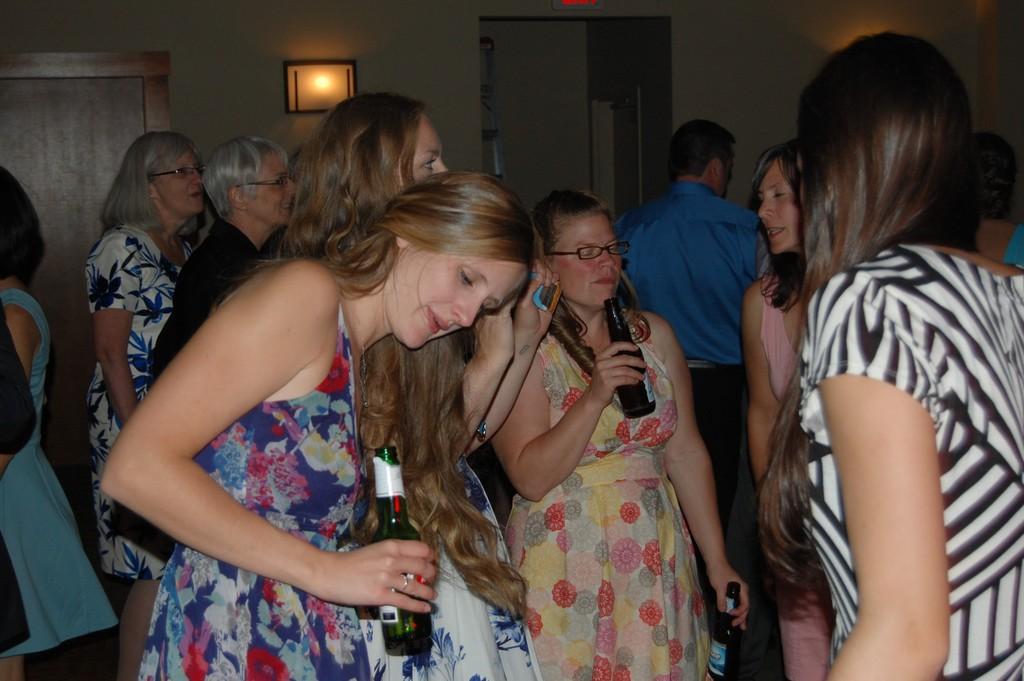How would you summarize this image in a sentence or two? In this image we can see a few people standing, among them some people are holding the bottles, there are some doors, lights and the wall. 